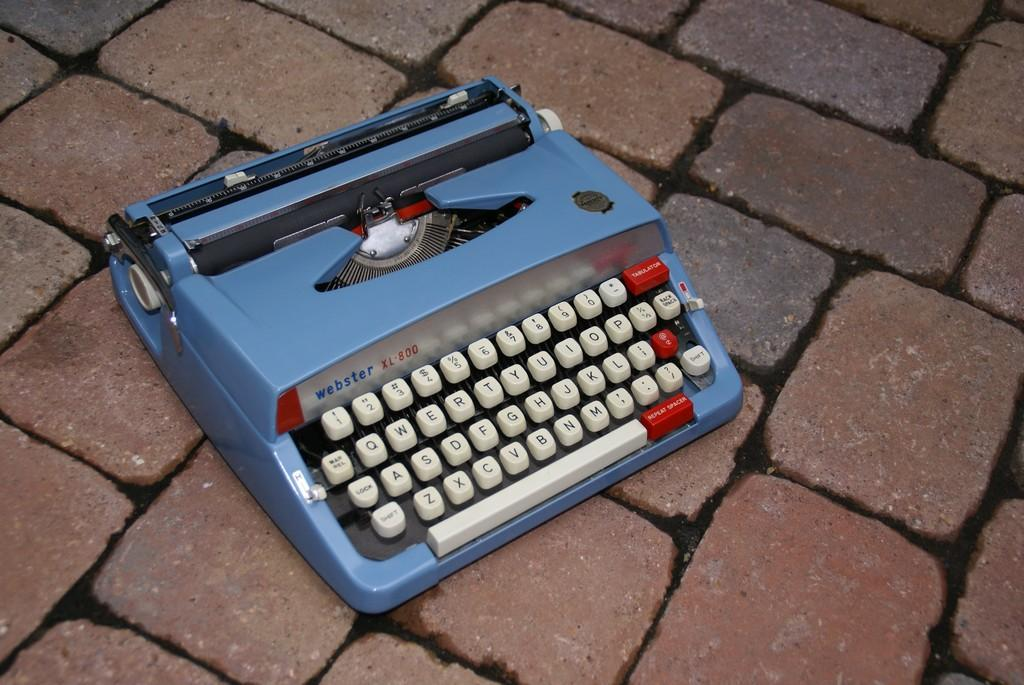<image>
Provide a brief description of the given image. Blue Webster typewriter modeled XL-800 placed on the ground. 